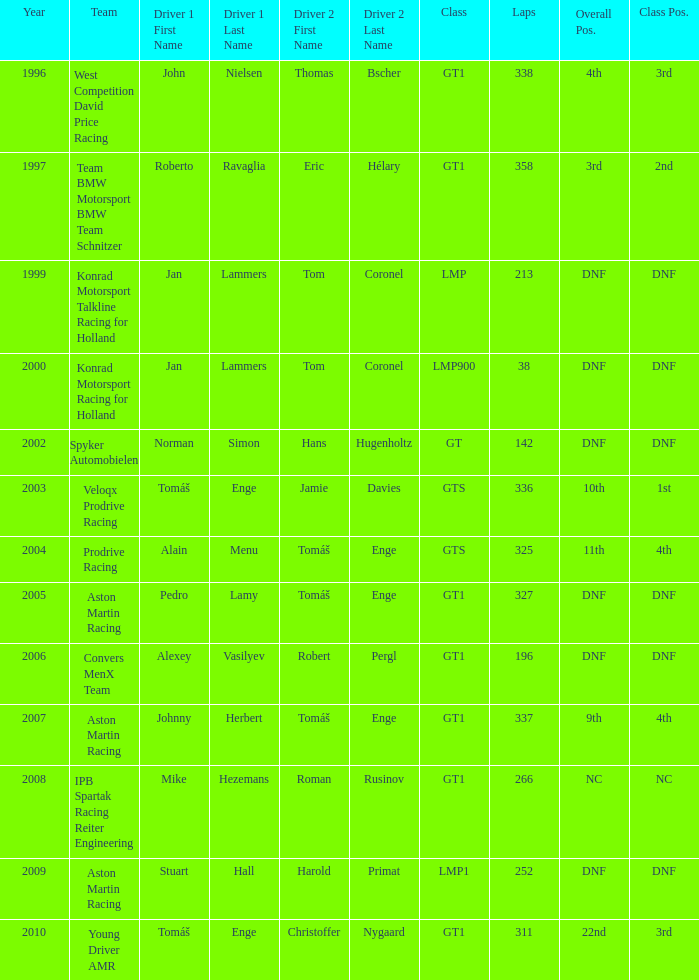Would you mind parsing the complete table? {'header': ['Year', 'Team', 'Driver 1 First Name', 'Driver 1 Last Name', 'Driver 2 First Name', 'Driver 2 Last Name', 'Class', 'Laps', 'Overall Pos.', 'Class Pos.'], 'rows': [['1996', 'West Competition David Price Racing', 'John', 'Nielsen', 'Thomas', 'Bscher', 'GT1', '338', '4th', '3rd'], ['1997', 'Team BMW Motorsport BMW Team Schnitzer', 'Roberto', 'Ravaglia', 'Eric', 'Hélary', 'GT1', '358', '3rd', '2nd'], ['1999', 'Konrad Motorsport Talkline Racing for Holland', 'Jan', 'Lammers', 'Tom', 'Coronel', 'LMP', '213', 'DNF', 'DNF'], ['2000', 'Konrad Motorsport Racing for Holland', 'Jan', 'Lammers', 'Tom', 'Coronel', 'LMP900', '38', 'DNF', 'DNF'], ['2002', 'Spyker Automobielen', 'Norman', 'Simon', 'Hans', 'Hugenholtz', 'GT', '142', 'DNF', 'DNF'], ['2003', 'Veloqx Prodrive Racing', 'Tomáš', 'Enge', 'Jamie', 'Davies', 'GTS', '336', '10th', '1st'], ['2004', 'Prodrive Racing', 'Alain', 'Menu', 'Tomáš', 'Enge', 'GTS', '325', '11th', '4th'], ['2005', 'Aston Martin Racing', 'Pedro', 'Lamy', 'Tomáš', 'Enge', 'GT1', '327', 'DNF', 'DNF'], ['2006', 'Convers MenX Team', 'Alexey', 'Vasilyev', 'Robert', 'Pergl', 'GT1', '196', 'DNF', 'DNF'], ['2007', 'Aston Martin Racing', 'Johnny', 'Herbert', 'Tomáš', 'Enge', 'GT1', '337', '9th', '4th'], ['2008', 'IPB Spartak Racing Reiter Engineering', 'Mike', 'Hezemans', 'Roman', 'Rusinov', 'GT1', '266', 'NC', 'NC'], ['2009', 'Aston Martin Racing', 'Stuart', 'Hall', 'Harold', 'Primat', 'LMP1', '252', 'DNF', 'DNF'], ['2010', 'Young Driver AMR', 'Tomáš', 'Enge', 'Christoffer', 'Nygaard', 'GT1', '311', '22nd', '3rd']]} What was the position in 1997? 3rd. 